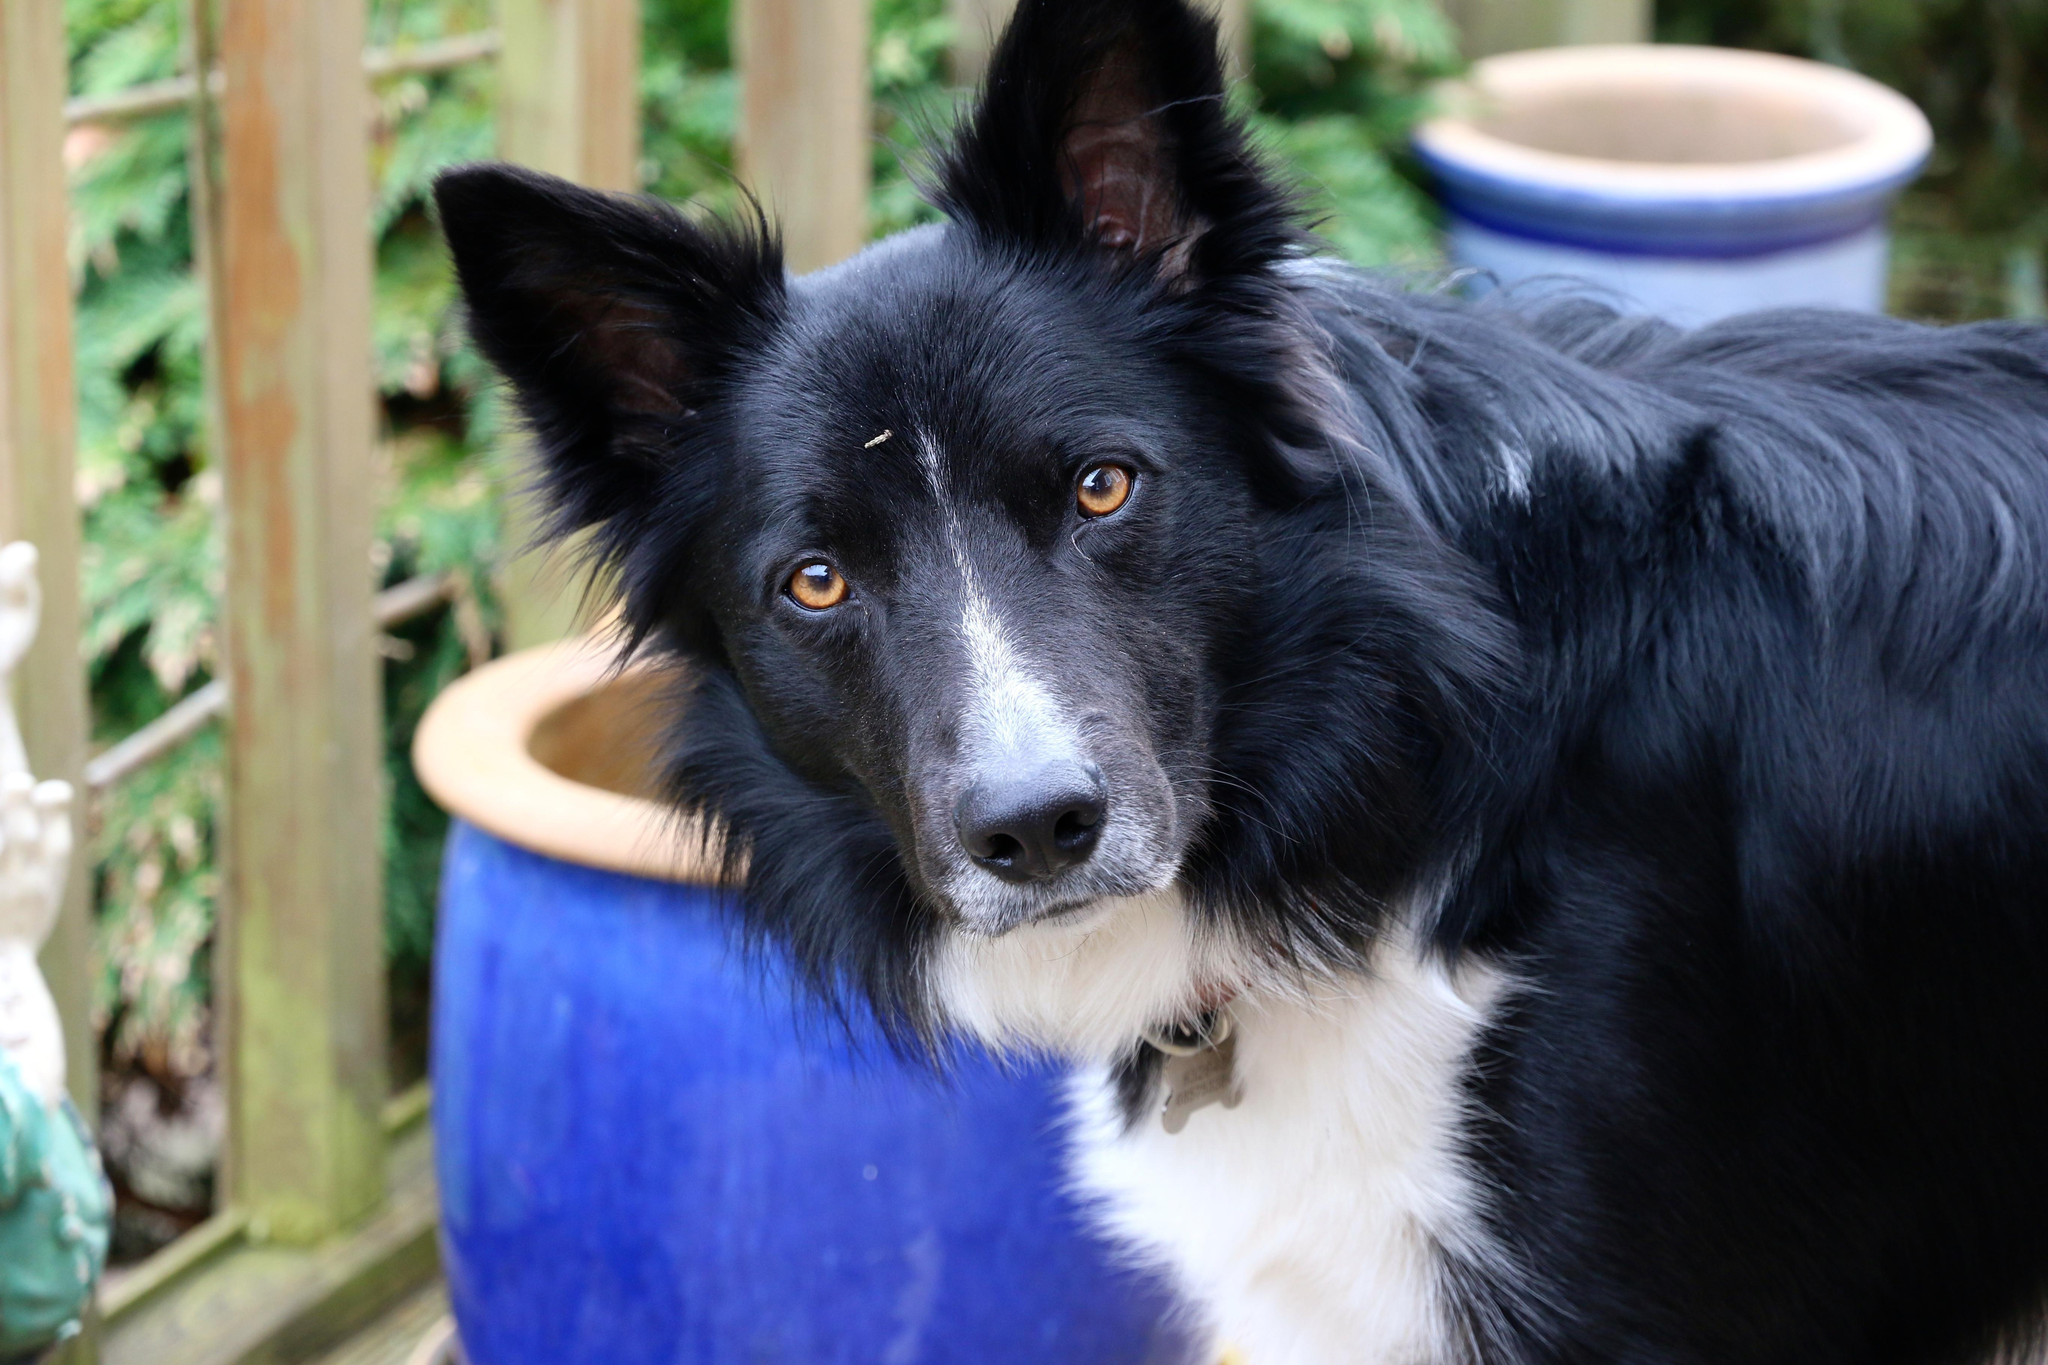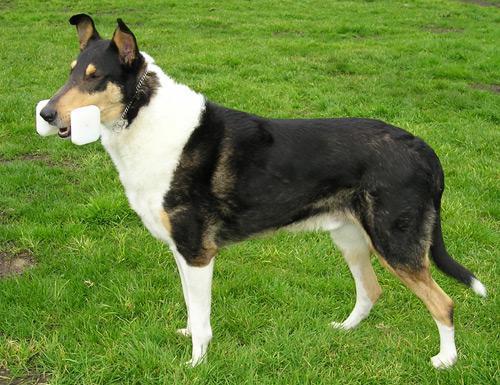The first image is the image on the left, the second image is the image on the right. Assess this claim about the two images: "Right image shows a dog standing on grass, with its body turned rightward.". Correct or not? Answer yes or no. No. The first image is the image on the left, the second image is the image on the right. For the images displayed, is the sentence "In one of the images there is a dog standing in the grass and looking away from the camera." factually correct? Answer yes or no. Yes. 